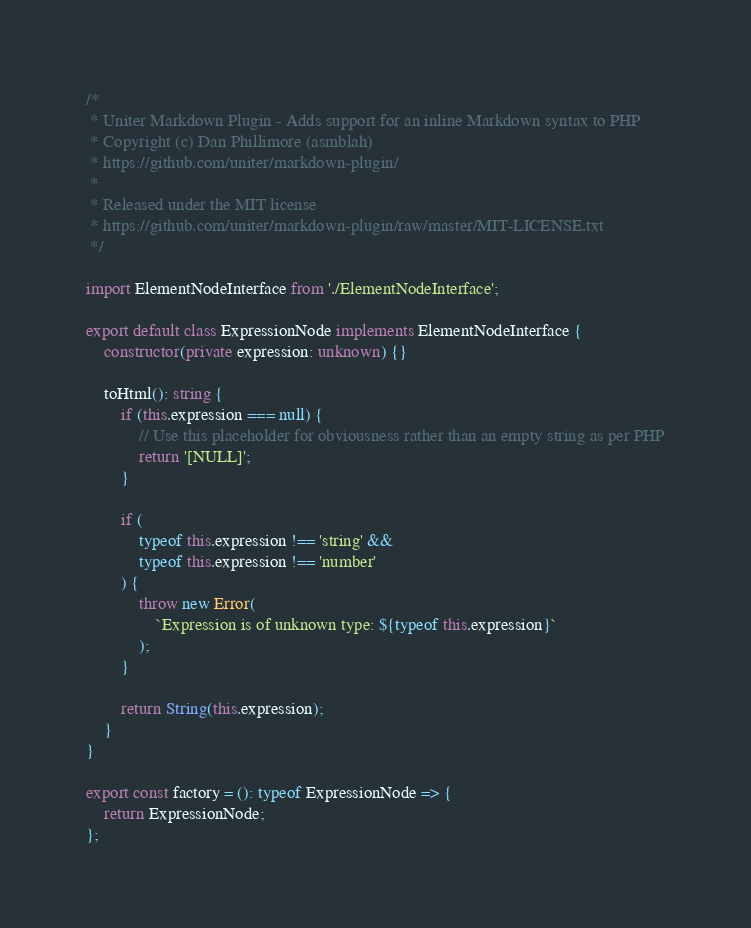Convert code to text. <code><loc_0><loc_0><loc_500><loc_500><_TypeScript_>/*
 * Uniter Markdown Plugin - Adds support for an inline Markdown syntax to PHP
 * Copyright (c) Dan Phillimore (asmblah)
 * https://github.com/uniter/markdown-plugin/
 *
 * Released under the MIT license
 * https://github.com/uniter/markdown-plugin/raw/master/MIT-LICENSE.txt
 */

import ElementNodeInterface from './ElementNodeInterface';

export default class ExpressionNode implements ElementNodeInterface {
    constructor(private expression: unknown) {}

    toHtml(): string {
        if (this.expression === null) {
            // Use this placeholder for obviousness rather than an empty string as per PHP
            return '[NULL]';
        }

        if (
            typeof this.expression !== 'string' &&
            typeof this.expression !== 'number'
        ) {
            throw new Error(
                `Expression is of unknown type: ${typeof this.expression}`
            );
        }

        return String(this.expression);
    }
}

export const factory = (): typeof ExpressionNode => {
    return ExpressionNode;
};
</code> 